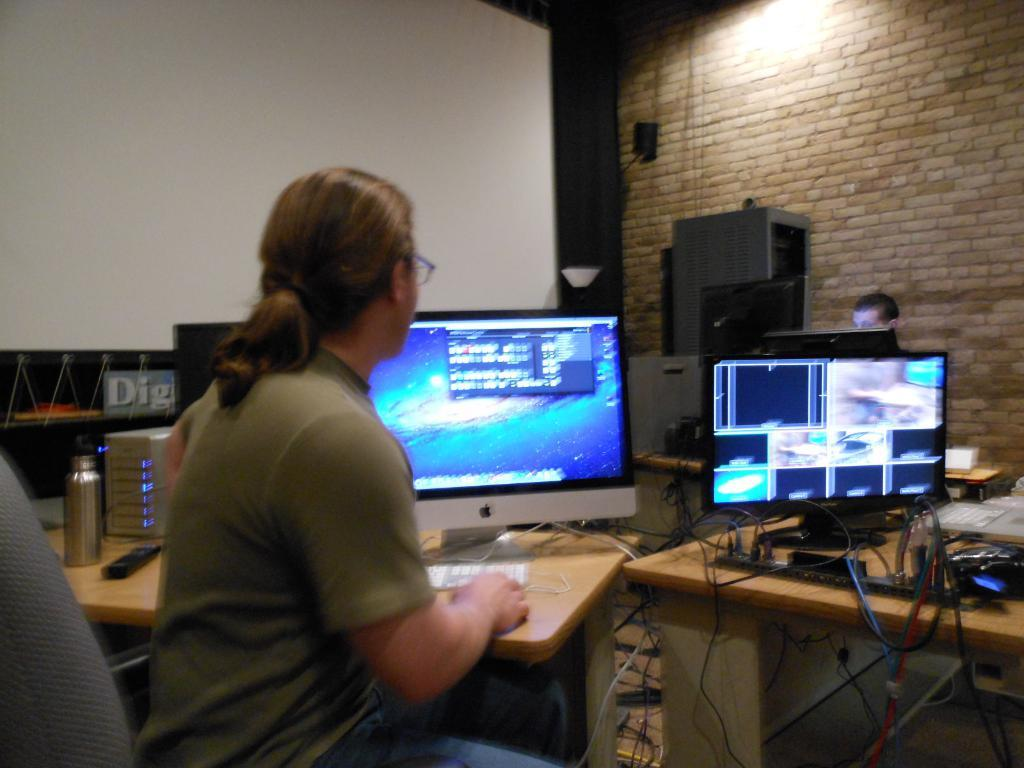<image>
Relay a brief, clear account of the picture shown. A woman sitting in a chair in front of an Apple computer with a sign saying "Dig" in the background. 